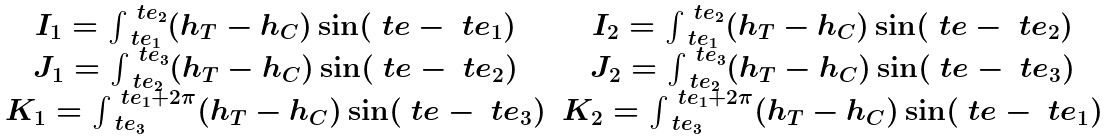<formula> <loc_0><loc_0><loc_500><loc_500>\begin{array} { c c c } I _ { 1 } = \int _ { \ t e _ { 1 } } ^ { \ t e _ { 2 } } ( h _ { T } - h _ { C } ) \sin ( \ t e - \ t e _ { 1 } ) & I _ { 2 } = \int _ { \ t e _ { 1 } } ^ { \ t e _ { 2 } } ( h _ { T } - h _ { C } ) \sin ( \ t e - \ t e _ { 2 } ) \\ J _ { 1 } = \int _ { \ t e _ { 2 } } ^ { \ t e _ { 3 } } ( h _ { T } - h _ { C } ) \sin ( \ t e - \ t e _ { 2 } ) & J _ { 2 } = \int _ { \ t e _ { 2 } } ^ { \ t e _ { 3 } } ( h _ { T } - h _ { C } ) \sin ( \ t e - \ t e _ { 3 } ) \\ K _ { 1 } = \int _ { \ t e _ { 3 } } ^ { \ t e _ { 1 } + 2 \pi } ( h _ { T } - h _ { C } ) \sin ( \ t e - \ t e _ { 3 } ) & K _ { 2 } = \int _ { \ t e _ { 3 } } ^ { \ t e _ { 1 } + 2 \pi } ( h _ { T } - h _ { C } ) \sin ( \ t e - \ t e _ { 1 } ) \end{array}</formula> 